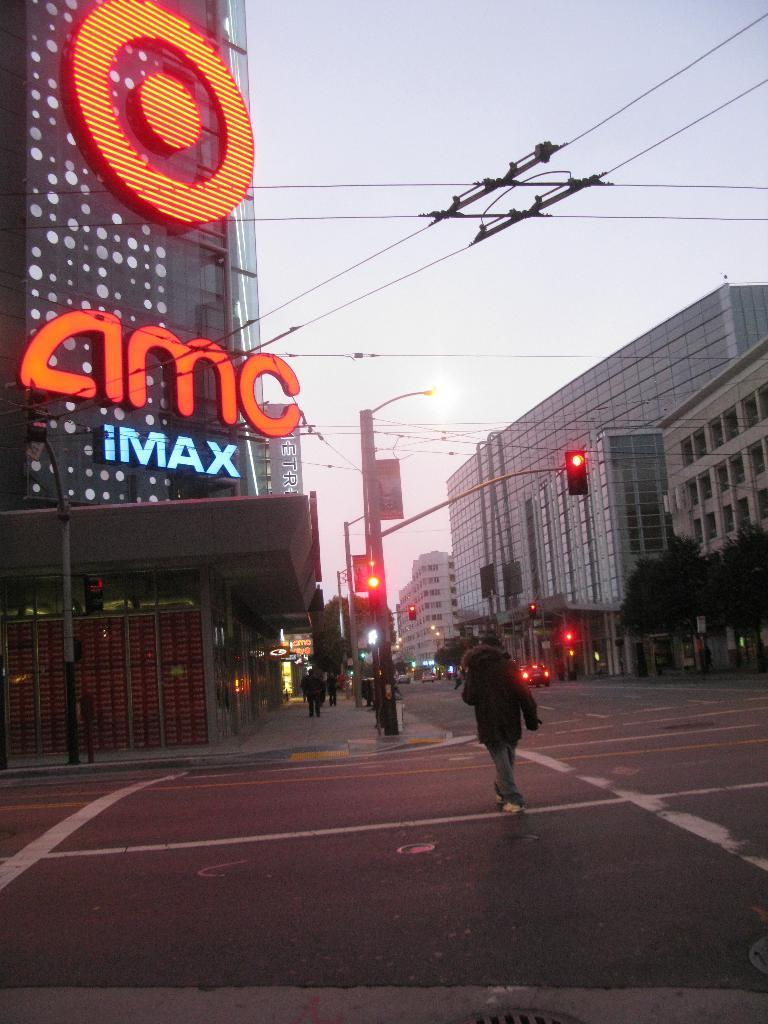<image>
Present a compact description of the photo's key features. A street scene with an advert for IMAX to the left. 